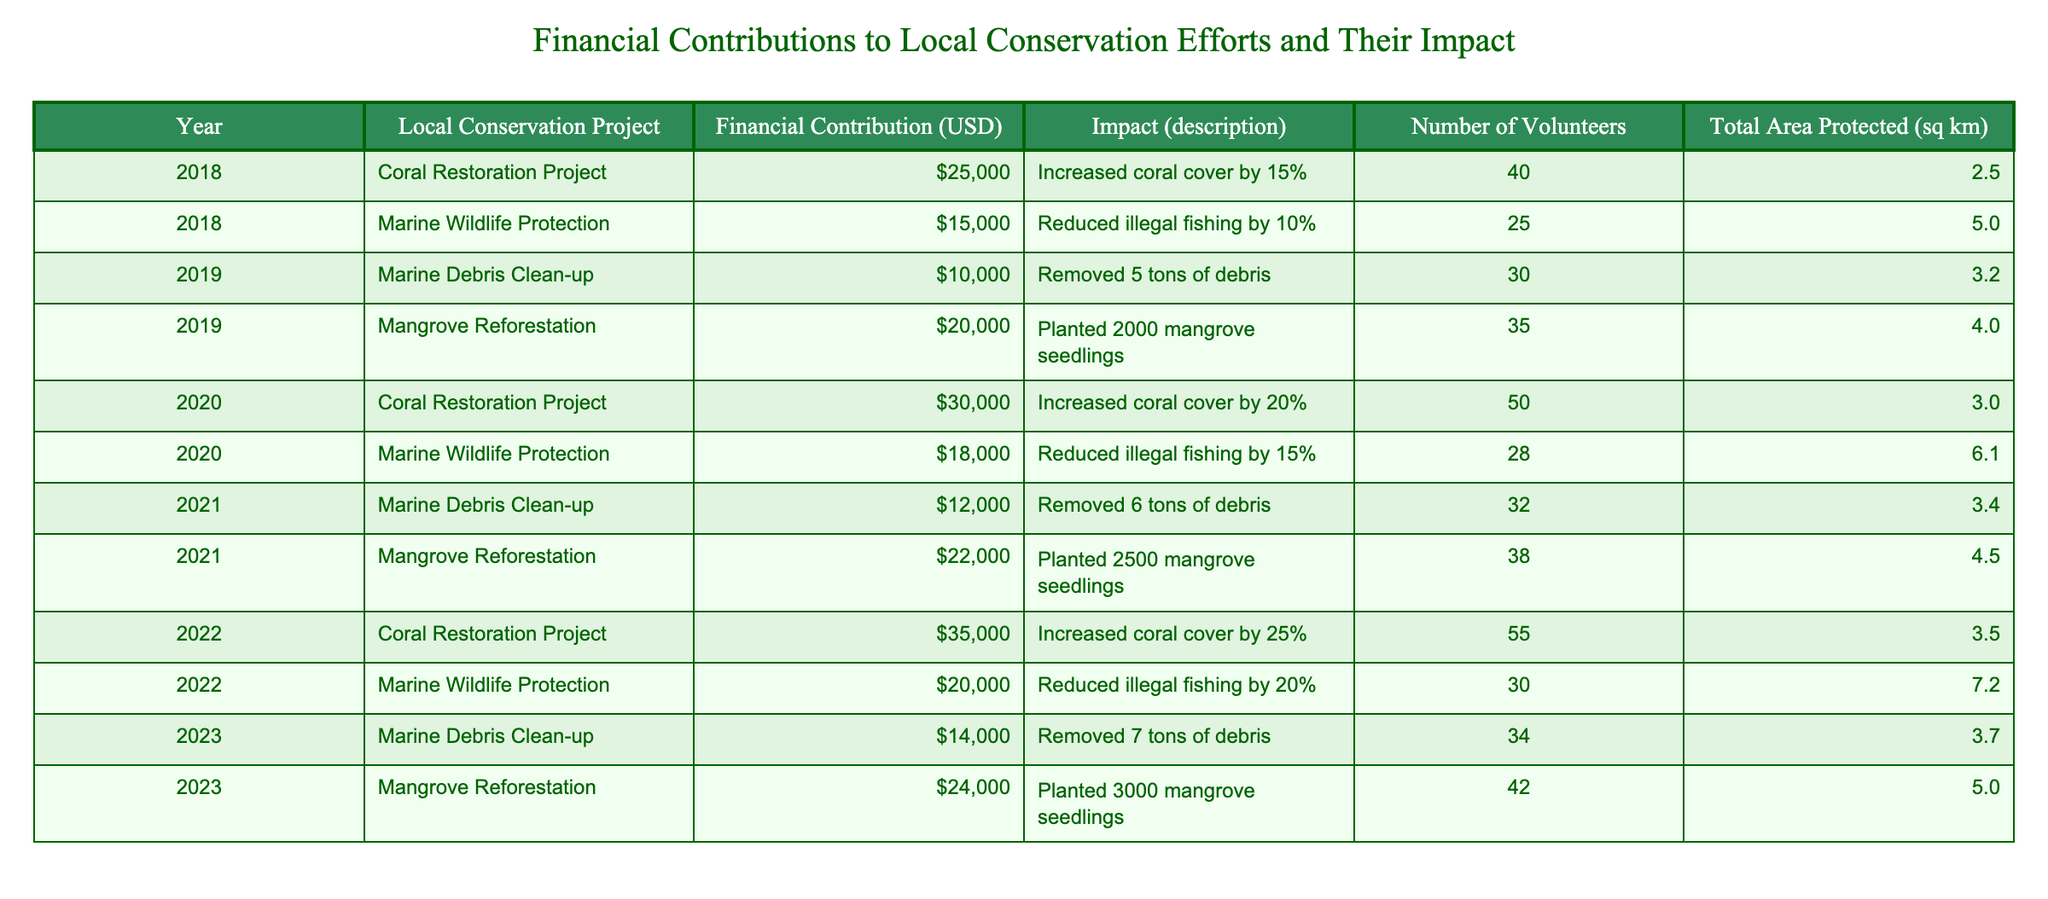What was the financial contribution to the Coral Restoration Project in 2021? The table lists the financial contributions for each project by year. Looking under the 'Year' column for 2021 and the 'Local Conservation Project' for Coral Restoration Project, the corresponding 'Financial Contribution (USD)' is $0. Therefore, the answer is $0.
Answer: $0 Which local conservation project had the highest financial contribution in 2022? In 2022, the table shows two projects: Coral Restoration Project with a contribution of $35,000 and Marine Wildlife Protection with $20,000. The higher contribution is from the Coral Restoration Project.
Answer: Coral Restoration Project How much total funding was contributed to Mangrove Reforestation from 2018 to 2023? Adding the financial contributions for Mangrove Reforestation across the years: $20,000 (2019) + $22,000 (2021) + $24,000 (2023) = $66,000. Thus, the total funding is $66,000.
Answer: $66,000 Did the Marine Debris Clean-up project ever have a financial contribution greater than $15,000? By checking the table, we can see that the financial contributions for the Marine Debris Clean-up project were $10,000 (2019), $12,000 (2021), and $14,000 (2023). None exceed $15,000.
Answer: No What is the total area protected across all projects in 2019? Referring to the table, for 2019, the Marine Debris Clean-up protected 3.2 sq km and Mangrove Reforestation protected 4.0 sq km. Adding these: 3.2 + 4.0 = 7.2 sq km is the total area protected.
Answer: 7.2 sq km Which year had the largest number of volunteers and how many were there? The highest number of volunteers is recorded in 2022 for the Coral Restoration Project with 55 volunteers. This is the maximum across all years.
Answer: 55 volunteers What was the impact description of the Marine Wildlife Protection in 2020? Looking under the 'Year' column for 2020 and referring to the corresponding row for Marine Wildlife Protection, the impact description shows "Reduced illegal fishing by 15%."
Answer: Reduced illegal fishing by 15% Calculate the average financial contribution for all conservation projects in 2020. The financial contributions for 2020 were $30,000 (Coral Restoration) + $18,000 (Marine Wildlife Protection) = $48,000. There are 2 projects in 2020, so the average is 48,000 / 2 = 24,000.
Answer: $24,000 